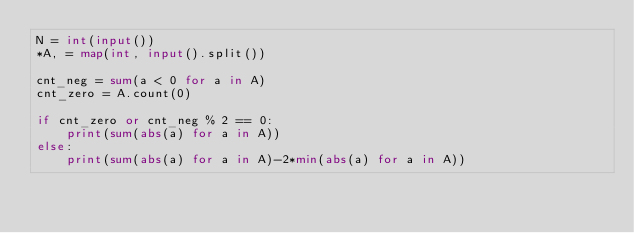<code> <loc_0><loc_0><loc_500><loc_500><_Python_>N = int(input())
*A, = map(int, input().split())

cnt_neg = sum(a < 0 for a in A)
cnt_zero = A.count(0)

if cnt_zero or cnt_neg % 2 == 0:
    print(sum(abs(a) for a in A))
else:
    print(sum(abs(a) for a in A)-2*min(abs(a) for a in A))
</code> 